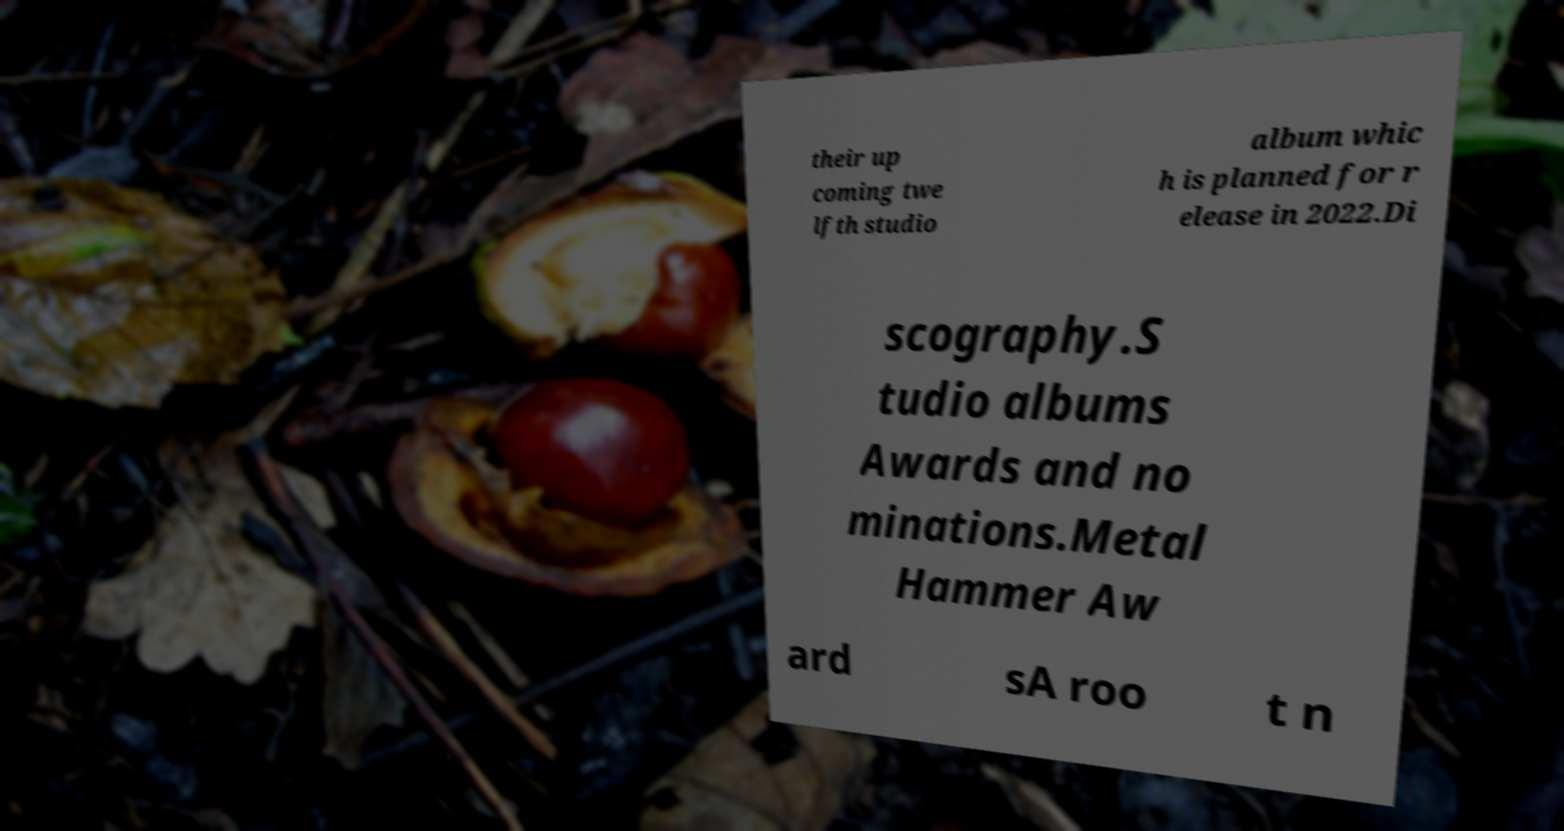What messages or text are displayed in this image? I need them in a readable, typed format. their up coming twe lfth studio album whic h is planned for r elease in 2022.Di scography.S tudio albums Awards and no minations.Metal Hammer Aw ard sA roo t n 